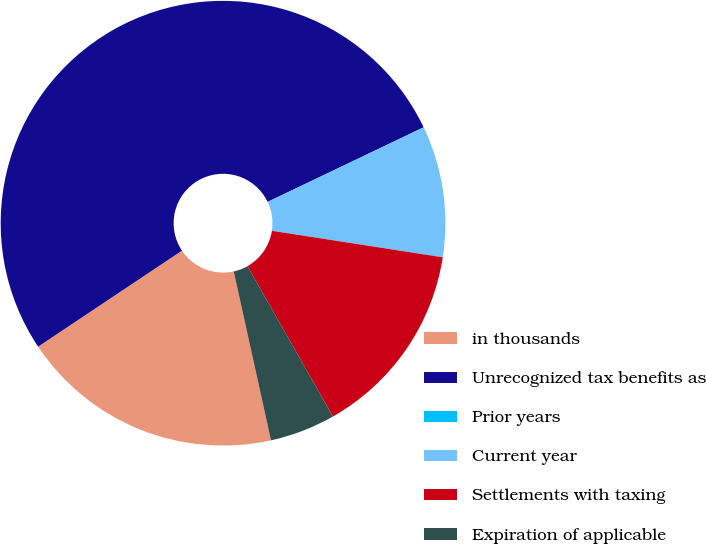Convert chart. <chart><loc_0><loc_0><loc_500><loc_500><pie_chart><fcel>in thousands<fcel>Unrecognized tax benefits as<fcel>Prior years<fcel>Current year<fcel>Settlements with taxing<fcel>Expiration of applicable<nl><fcel>19.09%<fcel>52.27%<fcel>0.0%<fcel>9.55%<fcel>14.32%<fcel>4.77%<nl></chart> 